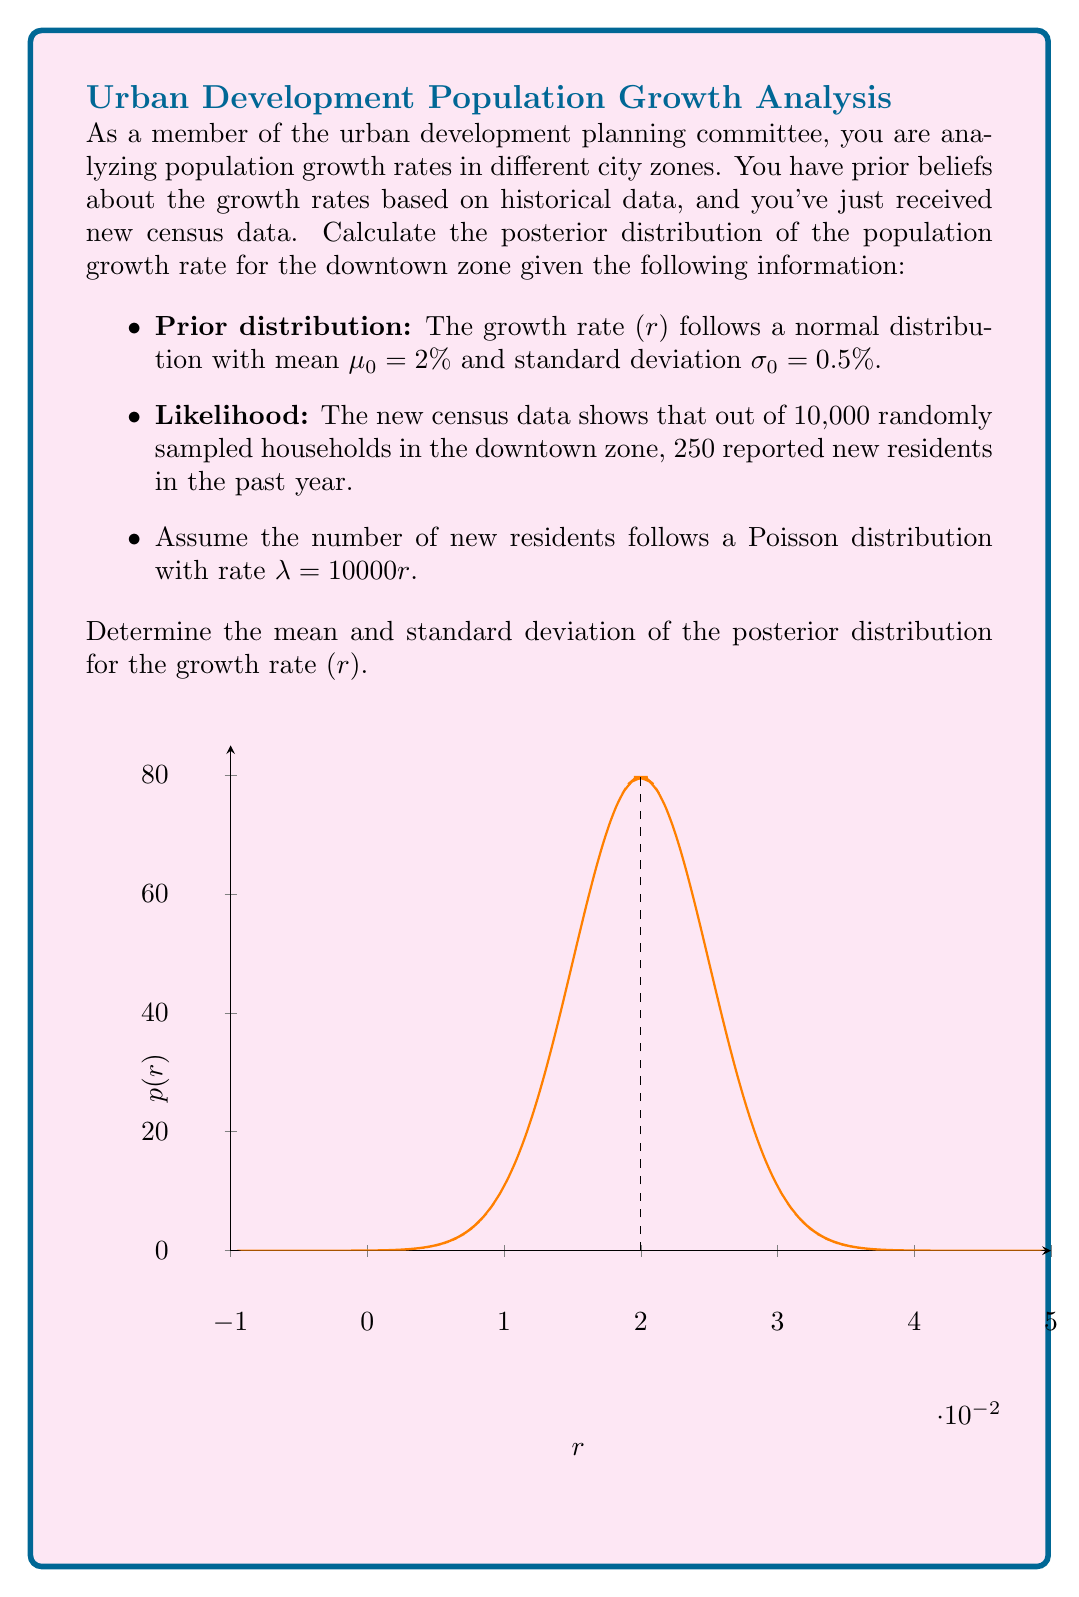Show me your answer to this math problem. Let's approach this step-by-step using Bayesian inference:

1) The prior distribution is normal: $r \sim N(\mu_0, \sigma_0^2)$ where $\mu_0 = 0.02$ and $\sigma_0 = 0.005$.

2) The likelihood function is Poisson with rate $\lambda = 10000r$. Given 250 new residents, the likelihood is:

   $L(r|data) = \frac{(10000r)^{250} e^{-10000r}}{250!}$

3) For conjugate prior-likelihood pairs, the posterior distribution would also be normal. However, this is not a conjugate pair, so we need to use numerical methods or approximations.

4) We can use Laplace approximation, which approximates the posterior as a normal distribution centered at the mode of the posterior.

5) The log-posterior (ignoring constants) is:

   $\log p(r|data) \propto -\frac{(r-0.02)^2}{2(0.005)^2} + 250\log(10000r) - 10000r$

6) To find the mode, we differentiate and set to zero:

   $\frac{d}{dr}\log p(r|data) = -\frac{r-0.02}{(0.005)^2} + \frac{250}{r} - 10000 = 0$

7) Solving this numerically (e.g., using Newton's method) gives the posterior mode: $\hat{r} \approx 0.0253$.

8) The second derivative at this point gives the inverse of the posterior variance:

   $-\frac{d^2}{dr^2}\log p(r|data) = \frac{1}{(0.005)^2} + \frac{250}{r^2} \approx 40000 + 390625 = 430625$

9) Therefore, the posterior standard deviation is approximately $\frac{1}{\sqrt{430625}} \approx 0.00152$.

Thus, the posterior distribution can be approximated as:

$r|data \sim N(0.0253, 0.00152^2)$
Answer: Posterior distribution: $N(0.0253, 0.00152^2)$ 